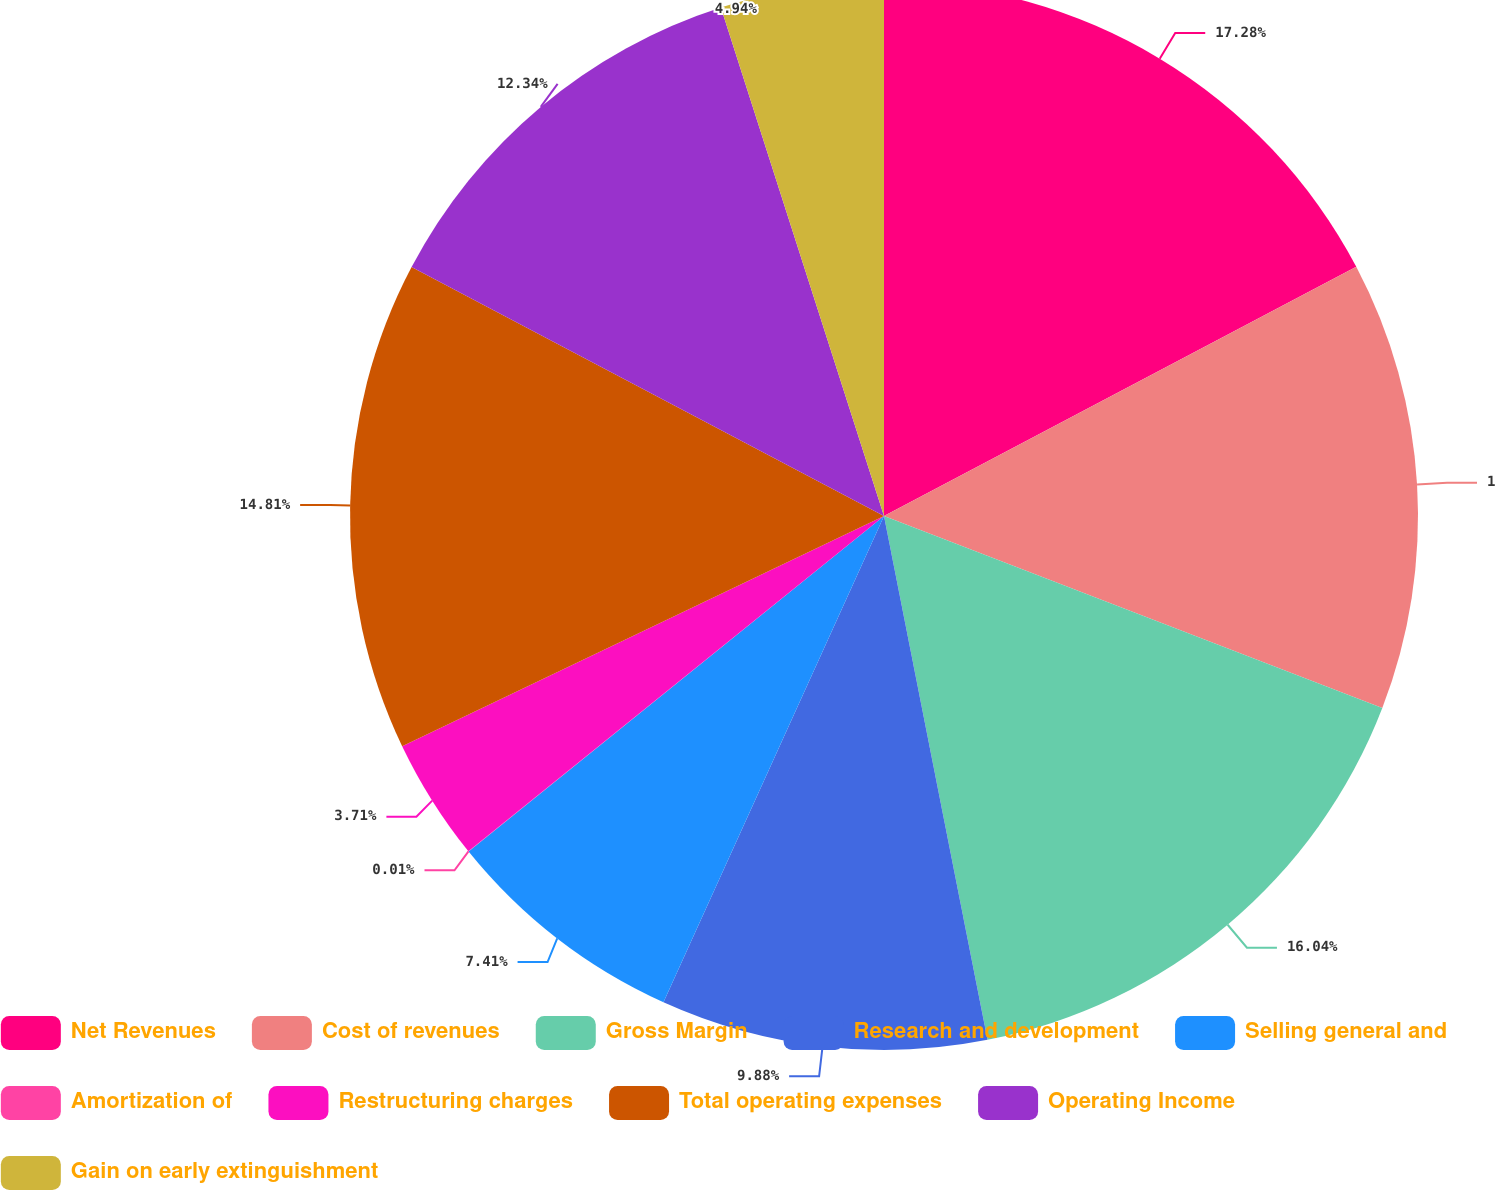<chart> <loc_0><loc_0><loc_500><loc_500><pie_chart><fcel>Net Revenues<fcel>Cost of revenues<fcel>Gross Margin<fcel>Research and development<fcel>Selling general and<fcel>Amortization of<fcel>Restructuring charges<fcel>Total operating expenses<fcel>Operating Income<fcel>Gain on early extinguishment<nl><fcel>17.27%<fcel>13.58%<fcel>16.04%<fcel>9.88%<fcel>7.41%<fcel>0.01%<fcel>3.71%<fcel>14.81%<fcel>12.34%<fcel>4.94%<nl></chart> 